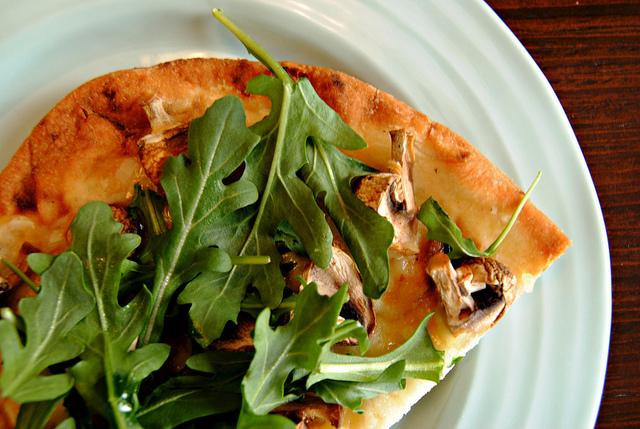What herb is on the pizza?
Answer briefly. Arugula. Are the greens on top cooked or raw?
Keep it brief. Raw. Are there any mushrooms on this pizza?
Short answer required. Yes. 